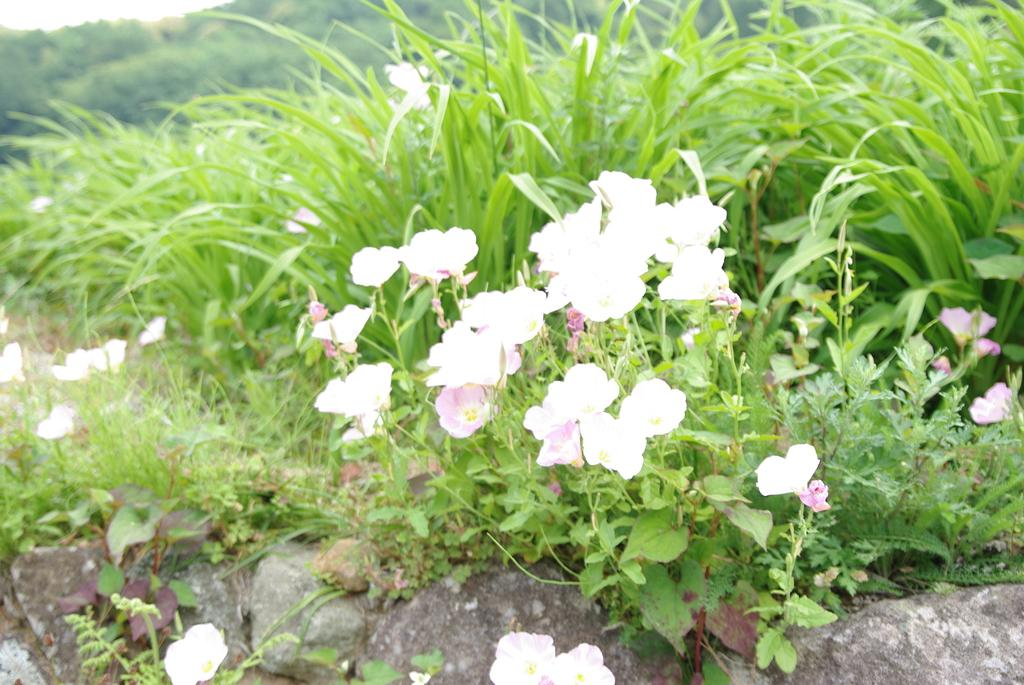What is located in the center of the image? There is grass, plants with flowers, and stones in the center of the image. Can you describe the plants with flowers in the image? The plants with flowers are located in the center of the image. What is visible in the background of the image? The background of the image is blurred. What type of insurance policy is being discussed by the carpenter in the image? There is no carpenter or discussion of insurance policies present in the image. 